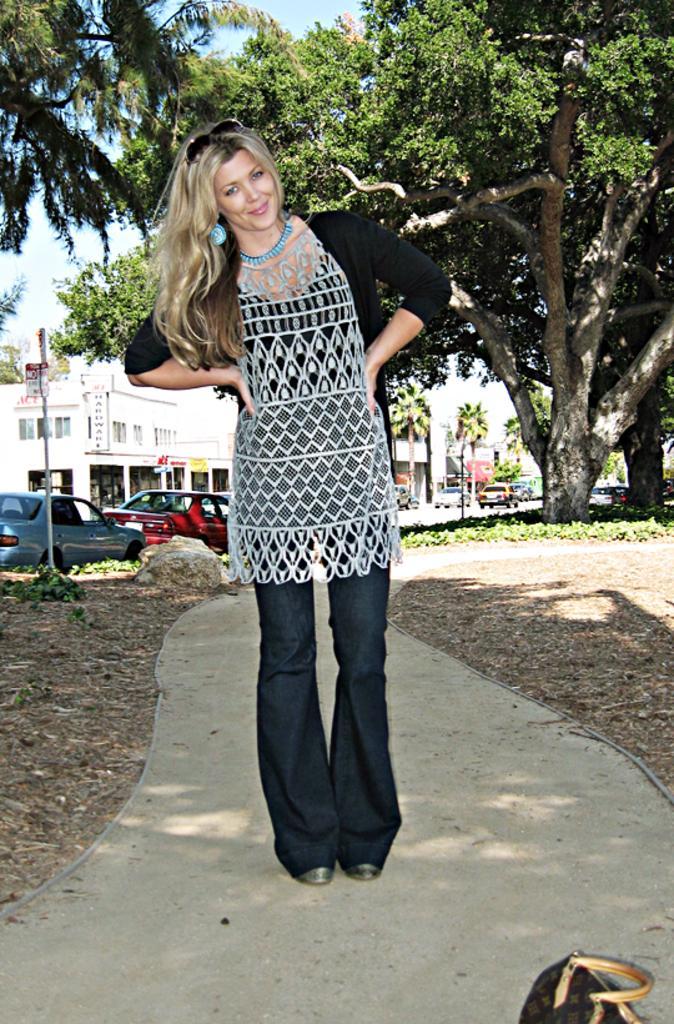Can you describe this image briefly? In the center of the image we can see women. In the background we can see cars, buildings, trees, and sky. 